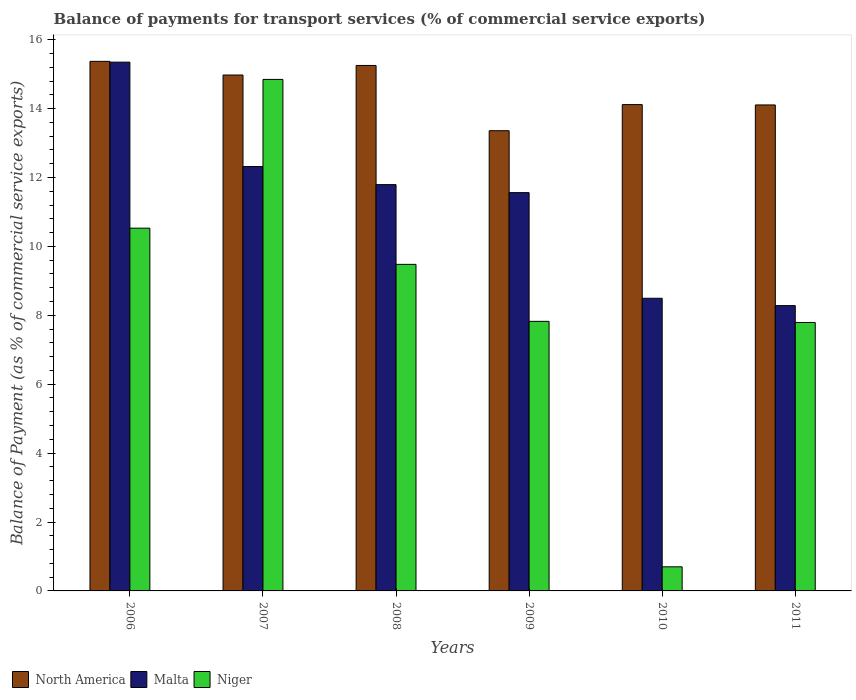Are the number of bars on each tick of the X-axis equal?
Keep it short and to the point. Yes. What is the balance of payments for transport services in Niger in 2007?
Provide a succinct answer. 14.85. Across all years, what is the maximum balance of payments for transport services in Malta?
Provide a succinct answer. 15.35. Across all years, what is the minimum balance of payments for transport services in Malta?
Keep it short and to the point. 8.28. In which year was the balance of payments for transport services in Malta minimum?
Give a very brief answer. 2011. What is the total balance of payments for transport services in Malta in the graph?
Offer a terse response. 67.79. What is the difference between the balance of payments for transport services in North America in 2006 and that in 2011?
Provide a succinct answer. 1.27. What is the difference between the balance of payments for transport services in Malta in 2008 and the balance of payments for transport services in North America in 2006?
Your answer should be compact. -3.58. What is the average balance of payments for transport services in Niger per year?
Offer a terse response. 8.53. In the year 2011, what is the difference between the balance of payments for transport services in Malta and balance of payments for transport services in Niger?
Ensure brevity in your answer.  0.49. In how many years, is the balance of payments for transport services in Niger greater than 9.2 %?
Give a very brief answer. 3. What is the ratio of the balance of payments for transport services in Niger in 2006 to that in 2010?
Your answer should be compact. 15.05. What is the difference between the highest and the second highest balance of payments for transport services in North America?
Your response must be concise. 0.12. What is the difference between the highest and the lowest balance of payments for transport services in Malta?
Ensure brevity in your answer.  7.07. Is the sum of the balance of payments for transport services in Malta in 2007 and 2011 greater than the maximum balance of payments for transport services in North America across all years?
Ensure brevity in your answer.  Yes. What does the 2nd bar from the left in 2007 represents?
Give a very brief answer. Malta. What does the 2nd bar from the right in 2011 represents?
Provide a succinct answer. Malta. How many years are there in the graph?
Your answer should be compact. 6. Where does the legend appear in the graph?
Your answer should be compact. Bottom left. How many legend labels are there?
Your answer should be very brief. 3. What is the title of the graph?
Your response must be concise. Balance of payments for transport services (% of commercial service exports). What is the label or title of the Y-axis?
Provide a short and direct response. Balance of Payment (as % of commercial service exports). What is the Balance of Payment (as % of commercial service exports) of North America in 2006?
Your answer should be compact. 15.37. What is the Balance of Payment (as % of commercial service exports) in Malta in 2006?
Give a very brief answer. 15.35. What is the Balance of Payment (as % of commercial service exports) in Niger in 2006?
Your answer should be very brief. 10.53. What is the Balance of Payment (as % of commercial service exports) of North America in 2007?
Provide a short and direct response. 14.97. What is the Balance of Payment (as % of commercial service exports) in Malta in 2007?
Your answer should be very brief. 12.32. What is the Balance of Payment (as % of commercial service exports) in Niger in 2007?
Offer a terse response. 14.85. What is the Balance of Payment (as % of commercial service exports) of North America in 2008?
Your response must be concise. 15.25. What is the Balance of Payment (as % of commercial service exports) of Malta in 2008?
Your answer should be very brief. 11.79. What is the Balance of Payment (as % of commercial service exports) of Niger in 2008?
Your answer should be very brief. 9.48. What is the Balance of Payment (as % of commercial service exports) of North America in 2009?
Keep it short and to the point. 13.36. What is the Balance of Payment (as % of commercial service exports) of Malta in 2009?
Offer a terse response. 11.56. What is the Balance of Payment (as % of commercial service exports) in Niger in 2009?
Keep it short and to the point. 7.82. What is the Balance of Payment (as % of commercial service exports) in North America in 2010?
Your answer should be compact. 14.12. What is the Balance of Payment (as % of commercial service exports) in Malta in 2010?
Your answer should be very brief. 8.49. What is the Balance of Payment (as % of commercial service exports) of Niger in 2010?
Provide a short and direct response. 0.7. What is the Balance of Payment (as % of commercial service exports) in North America in 2011?
Keep it short and to the point. 14.11. What is the Balance of Payment (as % of commercial service exports) in Malta in 2011?
Give a very brief answer. 8.28. What is the Balance of Payment (as % of commercial service exports) in Niger in 2011?
Provide a short and direct response. 7.79. Across all years, what is the maximum Balance of Payment (as % of commercial service exports) of North America?
Provide a succinct answer. 15.37. Across all years, what is the maximum Balance of Payment (as % of commercial service exports) in Malta?
Offer a terse response. 15.35. Across all years, what is the maximum Balance of Payment (as % of commercial service exports) in Niger?
Your answer should be very brief. 14.85. Across all years, what is the minimum Balance of Payment (as % of commercial service exports) of North America?
Your answer should be compact. 13.36. Across all years, what is the minimum Balance of Payment (as % of commercial service exports) of Malta?
Give a very brief answer. 8.28. Across all years, what is the minimum Balance of Payment (as % of commercial service exports) in Niger?
Your response must be concise. 0.7. What is the total Balance of Payment (as % of commercial service exports) in North America in the graph?
Keep it short and to the point. 87.18. What is the total Balance of Payment (as % of commercial service exports) in Malta in the graph?
Ensure brevity in your answer.  67.79. What is the total Balance of Payment (as % of commercial service exports) of Niger in the graph?
Offer a very short reply. 51.17. What is the difference between the Balance of Payment (as % of commercial service exports) of North America in 2006 and that in 2007?
Give a very brief answer. 0.4. What is the difference between the Balance of Payment (as % of commercial service exports) of Malta in 2006 and that in 2007?
Offer a terse response. 3.03. What is the difference between the Balance of Payment (as % of commercial service exports) of Niger in 2006 and that in 2007?
Provide a short and direct response. -4.32. What is the difference between the Balance of Payment (as % of commercial service exports) in North America in 2006 and that in 2008?
Ensure brevity in your answer.  0.12. What is the difference between the Balance of Payment (as % of commercial service exports) in Malta in 2006 and that in 2008?
Offer a very short reply. 3.55. What is the difference between the Balance of Payment (as % of commercial service exports) of Niger in 2006 and that in 2008?
Keep it short and to the point. 1.05. What is the difference between the Balance of Payment (as % of commercial service exports) of North America in 2006 and that in 2009?
Ensure brevity in your answer.  2.01. What is the difference between the Balance of Payment (as % of commercial service exports) of Malta in 2006 and that in 2009?
Provide a succinct answer. 3.79. What is the difference between the Balance of Payment (as % of commercial service exports) of Niger in 2006 and that in 2009?
Provide a short and direct response. 2.71. What is the difference between the Balance of Payment (as % of commercial service exports) in North America in 2006 and that in 2010?
Your response must be concise. 1.26. What is the difference between the Balance of Payment (as % of commercial service exports) in Malta in 2006 and that in 2010?
Your answer should be very brief. 6.85. What is the difference between the Balance of Payment (as % of commercial service exports) in Niger in 2006 and that in 2010?
Ensure brevity in your answer.  9.83. What is the difference between the Balance of Payment (as % of commercial service exports) in North America in 2006 and that in 2011?
Make the answer very short. 1.27. What is the difference between the Balance of Payment (as % of commercial service exports) in Malta in 2006 and that in 2011?
Your answer should be very brief. 7.07. What is the difference between the Balance of Payment (as % of commercial service exports) of Niger in 2006 and that in 2011?
Your response must be concise. 2.74. What is the difference between the Balance of Payment (as % of commercial service exports) of North America in 2007 and that in 2008?
Offer a very short reply. -0.28. What is the difference between the Balance of Payment (as % of commercial service exports) of Malta in 2007 and that in 2008?
Provide a short and direct response. 0.52. What is the difference between the Balance of Payment (as % of commercial service exports) in Niger in 2007 and that in 2008?
Ensure brevity in your answer.  5.37. What is the difference between the Balance of Payment (as % of commercial service exports) of North America in 2007 and that in 2009?
Make the answer very short. 1.62. What is the difference between the Balance of Payment (as % of commercial service exports) of Malta in 2007 and that in 2009?
Keep it short and to the point. 0.76. What is the difference between the Balance of Payment (as % of commercial service exports) of Niger in 2007 and that in 2009?
Offer a very short reply. 7.02. What is the difference between the Balance of Payment (as % of commercial service exports) of North America in 2007 and that in 2010?
Make the answer very short. 0.86. What is the difference between the Balance of Payment (as % of commercial service exports) of Malta in 2007 and that in 2010?
Provide a succinct answer. 3.82. What is the difference between the Balance of Payment (as % of commercial service exports) of Niger in 2007 and that in 2010?
Provide a succinct answer. 14.15. What is the difference between the Balance of Payment (as % of commercial service exports) in North America in 2007 and that in 2011?
Your answer should be very brief. 0.87. What is the difference between the Balance of Payment (as % of commercial service exports) in Malta in 2007 and that in 2011?
Give a very brief answer. 4.04. What is the difference between the Balance of Payment (as % of commercial service exports) of Niger in 2007 and that in 2011?
Your answer should be compact. 7.05. What is the difference between the Balance of Payment (as % of commercial service exports) in North America in 2008 and that in 2009?
Make the answer very short. 1.89. What is the difference between the Balance of Payment (as % of commercial service exports) of Malta in 2008 and that in 2009?
Offer a terse response. 0.23. What is the difference between the Balance of Payment (as % of commercial service exports) in Niger in 2008 and that in 2009?
Your response must be concise. 1.65. What is the difference between the Balance of Payment (as % of commercial service exports) of North America in 2008 and that in 2010?
Make the answer very short. 1.14. What is the difference between the Balance of Payment (as % of commercial service exports) in Malta in 2008 and that in 2010?
Provide a short and direct response. 3.3. What is the difference between the Balance of Payment (as % of commercial service exports) of Niger in 2008 and that in 2010?
Ensure brevity in your answer.  8.78. What is the difference between the Balance of Payment (as % of commercial service exports) of North America in 2008 and that in 2011?
Your answer should be very brief. 1.15. What is the difference between the Balance of Payment (as % of commercial service exports) of Malta in 2008 and that in 2011?
Provide a short and direct response. 3.51. What is the difference between the Balance of Payment (as % of commercial service exports) in Niger in 2008 and that in 2011?
Offer a very short reply. 1.69. What is the difference between the Balance of Payment (as % of commercial service exports) in North America in 2009 and that in 2010?
Your response must be concise. -0.76. What is the difference between the Balance of Payment (as % of commercial service exports) in Malta in 2009 and that in 2010?
Provide a short and direct response. 3.07. What is the difference between the Balance of Payment (as % of commercial service exports) of Niger in 2009 and that in 2010?
Provide a short and direct response. 7.12. What is the difference between the Balance of Payment (as % of commercial service exports) in North America in 2009 and that in 2011?
Your answer should be compact. -0.75. What is the difference between the Balance of Payment (as % of commercial service exports) in Malta in 2009 and that in 2011?
Give a very brief answer. 3.28. What is the difference between the Balance of Payment (as % of commercial service exports) in Niger in 2009 and that in 2011?
Your answer should be very brief. 0.03. What is the difference between the Balance of Payment (as % of commercial service exports) in North America in 2010 and that in 2011?
Keep it short and to the point. 0.01. What is the difference between the Balance of Payment (as % of commercial service exports) of Malta in 2010 and that in 2011?
Provide a short and direct response. 0.21. What is the difference between the Balance of Payment (as % of commercial service exports) of Niger in 2010 and that in 2011?
Keep it short and to the point. -7.09. What is the difference between the Balance of Payment (as % of commercial service exports) of North America in 2006 and the Balance of Payment (as % of commercial service exports) of Malta in 2007?
Provide a succinct answer. 3.05. What is the difference between the Balance of Payment (as % of commercial service exports) in North America in 2006 and the Balance of Payment (as % of commercial service exports) in Niger in 2007?
Make the answer very short. 0.52. What is the difference between the Balance of Payment (as % of commercial service exports) of Malta in 2006 and the Balance of Payment (as % of commercial service exports) of Niger in 2007?
Ensure brevity in your answer.  0.5. What is the difference between the Balance of Payment (as % of commercial service exports) in North America in 2006 and the Balance of Payment (as % of commercial service exports) in Malta in 2008?
Your response must be concise. 3.58. What is the difference between the Balance of Payment (as % of commercial service exports) of North America in 2006 and the Balance of Payment (as % of commercial service exports) of Niger in 2008?
Your response must be concise. 5.89. What is the difference between the Balance of Payment (as % of commercial service exports) of Malta in 2006 and the Balance of Payment (as % of commercial service exports) of Niger in 2008?
Ensure brevity in your answer.  5.87. What is the difference between the Balance of Payment (as % of commercial service exports) of North America in 2006 and the Balance of Payment (as % of commercial service exports) of Malta in 2009?
Provide a succinct answer. 3.81. What is the difference between the Balance of Payment (as % of commercial service exports) in North America in 2006 and the Balance of Payment (as % of commercial service exports) in Niger in 2009?
Provide a succinct answer. 7.55. What is the difference between the Balance of Payment (as % of commercial service exports) of Malta in 2006 and the Balance of Payment (as % of commercial service exports) of Niger in 2009?
Keep it short and to the point. 7.52. What is the difference between the Balance of Payment (as % of commercial service exports) of North America in 2006 and the Balance of Payment (as % of commercial service exports) of Malta in 2010?
Your answer should be very brief. 6.88. What is the difference between the Balance of Payment (as % of commercial service exports) in North America in 2006 and the Balance of Payment (as % of commercial service exports) in Niger in 2010?
Make the answer very short. 14.67. What is the difference between the Balance of Payment (as % of commercial service exports) in Malta in 2006 and the Balance of Payment (as % of commercial service exports) in Niger in 2010?
Provide a short and direct response. 14.65. What is the difference between the Balance of Payment (as % of commercial service exports) in North America in 2006 and the Balance of Payment (as % of commercial service exports) in Malta in 2011?
Make the answer very short. 7.09. What is the difference between the Balance of Payment (as % of commercial service exports) in North America in 2006 and the Balance of Payment (as % of commercial service exports) in Niger in 2011?
Give a very brief answer. 7.58. What is the difference between the Balance of Payment (as % of commercial service exports) in Malta in 2006 and the Balance of Payment (as % of commercial service exports) in Niger in 2011?
Give a very brief answer. 7.56. What is the difference between the Balance of Payment (as % of commercial service exports) in North America in 2007 and the Balance of Payment (as % of commercial service exports) in Malta in 2008?
Your response must be concise. 3.18. What is the difference between the Balance of Payment (as % of commercial service exports) in North America in 2007 and the Balance of Payment (as % of commercial service exports) in Niger in 2008?
Provide a short and direct response. 5.5. What is the difference between the Balance of Payment (as % of commercial service exports) in Malta in 2007 and the Balance of Payment (as % of commercial service exports) in Niger in 2008?
Offer a terse response. 2.84. What is the difference between the Balance of Payment (as % of commercial service exports) in North America in 2007 and the Balance of Payment (as % of commercial service exports) in Malta in 2009?
Your answer should be very brief. 3.41. What is the difference between the Balance of Payment (as % of commercial service exports) in North America in 2007 and the Balance of Payment (as % of commercial service exports) in Niger in 2009?
Keep it short and to the point. 7.15. What is the difference between the Balance of Payment (as % of commercial service exports) in Malta in 2007 and the Balance of Payment (as % of commercial service exports) in Niger in 2009?
Keep it short and to the point. 4.49. What is the difference between the Balance of Payment (as % of commercial service exports) of North America in 2007 and the Balance of Payment (as % of commercial service exports) of Malta in 2010?
Offer a very short reply. 6.48. What is the difference between the Balance of Payment (as % of commercial service exports) of North America in 2007 and the Balance of Payment (as % of commercial service exports) of Niger in 2010?
Give a very brief answer. 14.27. What is the difference between the Balance of Payment (as % of commercial service exports) in Malta in 2007 and the Balance of Payment (as % of commercial service exports) in Niger in 2010?
Offer a terse response. 11.62. What is the difference between the Balance of Payment (as % of commercial service exports) of North America in 2007 and the Balance of Payment (as % of commercial service exports) of Malta in 2011?
Your answer should be very brief. 6.69. What is the difference between the Balance of Payment (as % of commercial service exports) in North America in 2007 and the Balance of Payment (as % of commercial service exports) in Niger in 2011?
Your answer should be very brief. 7.18. What is the difference between the Balance of Payment (as % of commercial service exports) in Malta in 2007 and the Balance of Payment (as % of commercial service exports) in Niger in 2011?
Keep it short and to the point. 4.53. What is the difference between the Balance of Payment (as % of commercial service exports) of North America in 2008 and the Balance of Payment (as % of commercial service exports) of Malta in 2009?
Make the answer very short. 3.69. What is the difference between the Balance of Payment (as % of commercial service exports) of North America in 2008 and the Balance of Payment (as % of commercial service exports) of Niger in 2009?
Give a very brief answer. 7.43. What is the difference between the Balance of Payment (as % of commercial service exports) in Malta in 2008 and the Balance of Payment (as % of commercial service exports) in Niger in 2009?
Your answer should be compact. 3.97. What is the difference between the Balance of Payment (as % of commercial service exports) in North America in 2008 and the Balance of Payment (as % of commercial service exports) in Malta in 2010?
Provide a succinct answer. 6.76. What is the difference between the Balance of Payment (as % of commercial service exports) of North America in 2008 and the Balance of Payment (as % of commercial service exports) of Niger in 2010?
Offer a very short reply. 14.55. What is the difference between the Balance of Payment (as % of commercial service exports) in Malta in 2008 and the Balance of Payment (as % of commercial service exports) in Niger in 2010?
Offer a terse response. 11.09. What is the difference between the Balance of Payment (as % of commercial service exports) of North America in 2008 and the Balance of Payment (as % of commercial service exports) of Malta in 2011?
Make the answer very short. 6.97. What is the difference between the Balance of Payment (as % of commercial service exports) in North America in 2008 and the Balance of Payment (as % of commercial service exports) in Niger in 2011?
Make the answer very short. 7.46. What is the difference between the Balance of Payment (as % of commercial service exports) of Malta in 2008 and the Balance of Payment (as % of commercial service exports) of Niger in 2011?
Give a very brief answer. 4. What is the difference between the Balance of Payment (as % of commercial service exports) of North America in 2009 and the Balance of Payment (as % of commercial service exports) of Malta in 2010?
Offer a terse response. 4.86. What is the difference between the Balance of Payment (as % of commercial service exports) of North America in 2009 and the Balance of Payment (as % of commercial service exports) of Niger in 2010?
Keep it short and to the point. 12.66. What is the difference between the Balance of Payment (as % of commercial service exports) in Malta in 2009 and the Balance of Payment (as % of commercial service exports) in Niger in 2010?
Provide a succinct answer. 10.86. What is the difference between the Balance of Payment (as % of commercial service exports) in North America in 2009 and the Balance of Payment (as % of commercial service exports) in Malta in 2011?
Offer a terse response. 5.08. What is the difference between the Balance of Payment (as % of commercial service exports) of North America in 2009 and the Balance of Payment (as % of commercial service exports) of Niger in 2011?
Make the answer very short. 5.57. What is the difference between the Balance of Payment (as % of commercial service exports) in Malta in 2009 and the Balance of Payment (as % of commercial service exports) in Niger in 2011?
Your answer should be compact. 3.77. What is the difference between the Balance of Payment (as % of commercial service exports) in North America in 2010 and the Balance of Payment (as % of commercial service exports) in Malta in 2011?
Ensure brevity in your answer.  5.83. What is the difference between the Balance of Payment (as % of commercial service exports) of North America in 2010 and the Balance of Payment (as % of commercial service exports) of Niger in 2011?
Your answer should be very brief. 6.32. What is the difference between the Balance of Payment (as % of commercial service exports) in Malta in 2010 and the Balance of Payment (as % of commercial service exports) in Niger in 2011?
Ensure brevity in your answer.  0.7. What is the average Balance of Payment (as % of commercial service exports) of North America per year?
Make the answer very short. 14.53. What is the average Balance of Payment (as % of commercial service exports) in Malta per year?
Your answer should be very brief. 11.3. What is the average Balance of Payment (as % of commercial service exports) of Niger per year?
Provide a short and direct response. 8.53. In the year 2006, what is the difference between the Balance of Payment (as % of commercial service exports) in North America and Balance of Payment (as % of commercial service exports) in Malta?
Your answer should be compact. 0.02. In the year 2006, what is the difference between the Balance of Payment (as % of commercial service exports) of North America and Balance of Payment (as % of commercial service exports) of Niger?
Offer a terse response. 4.84. In the year 2006, what is the difference between the Balance of Payment (as % of commercial service exports) in Malta and Balance of Payment (as % of commercial service exports) in Niger?
Offer a very short reply. 4.82. In the year 2007, what is the difference between the Balance of Payment (as % of commercial service exports) in North America and Balance of Payment (as % of commercial service exports) in Malta?
Your answer should be very brief. 2.66. In the year 2007, what is the difference between the Balance of Payment (as % of commercial service exports) in North America and Balance of Payment (as % of commercial service exports) in Niger?
Give a very brief answer. 0.13. In the year 2007, what is the difference between the Balance of Payment (as % of commercial service exports) in Malta and Balance of Payment (as % of commercial service exports) in Niger?
Provide a short and direct response. -2.53. In the year 2008, what is the difference between the Balance of Payment (as % of commercial service exports) of North America and Balance of Payment (as % of commercial service exports) of Malta?
Provide a short and direct response. 3.46. In the year 2008, what is the difference between the Balance of Payment (as % of commercial service exports) in North America and Balance of Payment (as % of commercial service exports) in Niger?
Provide a short and direct response. 5.77. In the year 2008, what is the difference between the Balance of Payment (as % of commercial service exports) in Malta and Balance of Payment (as % of commercial service exports) in Niger?
Make the answer very short. 2.31. In the year 2009, what is the difference between the Balance of Payment (as % of commercial service exports) in North America and Balance of Payment (as % of commercial service exports) in Malta?
Offer a terse response. 1.8. In the year 2009, what is the difference between the Balance of Payment (as % of commercial service exports) of North America and Balance of Payment (as % of commercial service exports) of Niger?
Offer a very short reply. 5.53. In the year 2009, what is the difference between the Balance of Payment (as % of commercial service exports) of Malta and Balance of Payment (as % of commercial service exports) of Niger?
Ensure brevity in your answer.  3.74. In the year 2010, what is the difference between the Balance of Payment (as % of commercial service exports) of North America and Balance of Payment (as % of commercial service exports) of Malta?
Give a very brief answer. 5.62. In the year 2010, what is the difference between the Balance of Payment (as % of commercial service exports) of North America and Balance of Payment (as % of commercial service exports) of Niger?
Keep it short and to the point. 13.42. In the year 2010, what is the difference between the Balance of Payment (as % of commercial service exports) of Malta and Balance of Payment (as % of commercial service exports) of Niger?
Ensure brevity in your answer.  7.79. In the year 2011, what is the difference between the Balance of Payment (as % of commercial service exports) of North America and Balance of Payment (as % of commercial service exports) of Malta?
Make the answer very short. 5.82. In the year 2011, what is the difference between the Balance of Payment (as % of commercial service exports) of North America and Balance of Payment (as % of commercial service exports) of Niger?
Your answer should be very brief. 6.31. In the year 2011, what is the difference between the Balance of Payment (as % of commercial service exports) of Malta and Balance of Payment (as % of commercial service exports) of Niger?
Provide a short and direct response. 0.49. What is the ratio of the Balance of Payment (as % of commercial service exports) of North America in 2006 to that in 2007?
Offer a terse response. 1.03. What is the ratio of the Balance of Payment (as % of commercial service exports) of Malta in 2006 to that in 2007?
Your answer should be very brief. 1.25. What is the ratio of the Balance of Payment (as % of commercial service exports) in Niger in 2006 to that in 2007?
Provide a succinct answer. 0.71. What is the ratio of the Balance of Payment (as % of commercial service exports) in North America in 2006 to that in 2008?
Your answer should be very brief. 1.01. What is the ratio of the Balance of Payment (as % of commercial service exports) in Malta in 2006 to that in 2008?
Your response must be concise. 1.3. What is the ratio of the Balance of Payment (as % of commercial service exports) in Niger in 2006 to that in 2008?
Provide a short and direct response. 1.11. What is the ratio of the Balance of Payment (as % of commercial service exports) of North America in 2006 to that in 2009?
Provide a short and direct response. 1.15. What is the ratio of the Balance of Payment (as % of commercial service exports) in Malta in 2006 to that in 2009?
Your response must be concise. 1.33. What is the ratio of the Balance of Payment (as % of commercial service exports) of Niger in 2006 to that in 2009?
Your response must be concise. 1.35. What is the ratio of the Balance of Payment (as % of commercial service exports) of North America in 2006 to that in 2010?
Give a very brief answer. 1.09. What is the ratio of the Balance of Payment (as % of commercial service exports) in Malta in 2006 to that in 2010?
Provide a succinct answer. 1.81. What is the ratio of the Balance of Payment (as % of commercial service exports) in Niger in 2006 to that in 2010?
Your response must be concise. 15.05. What is the ratio of the Balance of Payment (as % of commercial service exports) in North America in 2006 to that in 2011?
Ensure brevity in your answer.  1.09. What is the ratio of the Balance of Payment (as % of commercial service exports) of Malta in 2006 to that in 2011?
Offer a very short reply. 1.85. What is the ratio of the Balance of Payment (as % of commercial service exports) of Niger in 2006 to that in 2011?
Keep it short and to the point. 1.35. What is the ratio of the Balance of Payment (as % of commercial service exports) of North America in 2007 to that in 2008?
Ensure brevity in your answer.  0.98. What is the ratio of the Balance of Payment (as % of commercial service exports) in Malta in 2007 to that in 2008?
Provide a succinct answer. 1.04. What is the ratio of the Balance of Payment (as % of commercial service exports) of Niger in 2007 to that in 2008?
Your answer should be very brief. 1.57. What is the ratio of the Balance of Payment (as % of commercial service exports) in North America in 2007 to that in 2009?
Keep it short and to the point. 1.12. What is the ratio of the Balance of Payment (as % of commercial service exports) in Malta in 2007 to that in 2009?
Provide a succinct answer. 1.07. What is the ratio of the Balance of Payment (as % of commercial service exports) in Niger in 2007 to that in 2009?
Give a very brief answer. 1.9. What is the ratio of the Balance of Payment (as % of commercial service exports) of North America in 2007 to that in 2010?
Your answer should be very brief. 1.06. What is the ratio of the Balance of Payment (as % of commercial service exports) in Malta in 2007 to that in 2010?
Offer a very short reply. 1.45. What is the ratio of the Balance of Payment (as % of commercial service exports) of Niger in 2007 to that in 2010?
Your answer should be compact. 21.22. What is the ratio of the Balance of Payment (as % of commercial service exports) of North America in 2007 to that in 2011?
Your answer should be compact. 1.06. What is the ratio of the Balance of Payment (as % of commercial service exports) of Malta in 2007 to that in 2011?
Provide a succinct answer. 1.49. What is the ratio of the Balance of Payment (as % of commercial service exports) in Niger in 2007 to that in 2011?
Provide a short and direct response. 1.91. What is the ratio of the Balance of Payment (as % of commercial service exports) in North America in 2008 to that in 2009?
Your answer should be very brief. 1.14. What is the ratio of the Balance of Payment (as % of commercial service exports) of Malta in 2008 to that in 2009?
Ensure brevity in your answer.  1.02. What is the ratio of the Balance of Payment (as % of commercial service exports) in Niger in 2008 to that in 2009?
Your response must be concise. 1.21. What is the ratio of the Balance of Payment (as % of commercial service exports) of North America in 2008 to that in 2010?
Offer a very short reply. 1.08. What is the ratio of the Balance of Payment (as % of commercial service exports) of Malta in 2008 to that in 2010?
Your response must be concise. 1.39. What is the ratio of the Balance of Payment (as % of commercial service exports) in Niger in 2008 to that in 2010?
Give a very brief answer. 13.55. What is the ratio of the Balance of Payment (as % of commercial service exports) of North America in 2008 to that in 2011?
Keep it short and to the point. 1.08. What is the ratio of the Balance of Payment (as % of commercial service exports) of Malta in 2008 to that in 2011?
Your answer should be compact. 1.42. What is the ratio of the Balance of Payment (as % of commercial service exports) of Niger in 2008 to that in 2011?
Give a very brief answer. 1.22. What is the ratio of the Balance of Payment (as % of commercial service exports) in North America in 2009 to that in 2010?
Your answer should be compact. 0.95. What is the ratio of the Balance of Payment (as % of commercial service exports) of Malta in 2009 to that in 2010?
Provide a short and direct response. 1.36. What is the ratio of the Balance of Payment (as % of commercial service exports) in Niger in 2009 to that in 2010?
Give a very brief answer. 11.18. What is the ratio of the Balance of Payment (as % of commercial service exports) in North America in 2009 to that in 2011?
Your answer should be very brief. 0.95. What is the ratio of the Balance of Payment (as % of commercial service exports) in Malta in 2009 to that in 2011?
Ensure brevity in your answer.  1.4. What is the ratio of the Balance of Payment (as % of commercial service exports) of Niger in 2009 to that in 2011?
Your answer should be very brief. 1. What is the ratio of the Balance of Payment (as % of commercial service exports) in Malta in 2010 to that in 2011?
Your answer should be very brief. 1.03. What is the ratio of the Balance of Payment (as % of commercial service exports) of Niger in 2010 to that in 2011?
Offer a terse response. 0.09. What is the difference between the highest and the second highest Balance of Payment (as % of commercial service exports) of North America?
Keep it short and to the point. 0.12. What is the difference between the highest and the second highest Balance of Payment (as % of commercial service exports) in Malta?
Keep it short and to the point. 3.03. What is the difference between the highest and the second highest Balance of Payment (as % of commercial service exports) in Niger?
Keep it short and to the point. 4.32. What is the difference between the highest and the lowest Balance of Payment (as % of commercial service exports) of North America?
Offer a terse response. 2.01. What is the difference between the highest and the lowest Balance of Payment (as % of commercial service exports) in Malta?
Your answer should be very brief. 7.07. What is the difference between the highest and the lowest Balance of Payment (as % of commercial service exports) of Niger?
Provide a short and direct response. 14.15. 